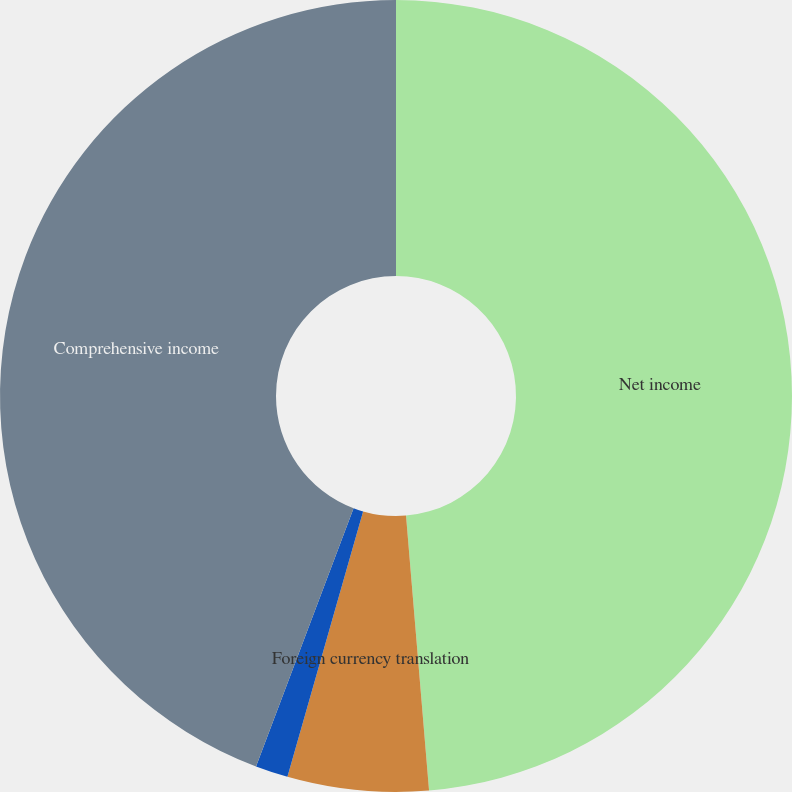<chart> <loc_0><loc_0><loc_500><loc_500><pie_chart><fcel>Net income<fcel>Foreign currency translation<fcel>Total other comprehensive<fcel>Comprehensive income<nl><fcel>48.67%<fcel>5.75%<fcel>1.33%<fcel>44.25%<nl></chart> 